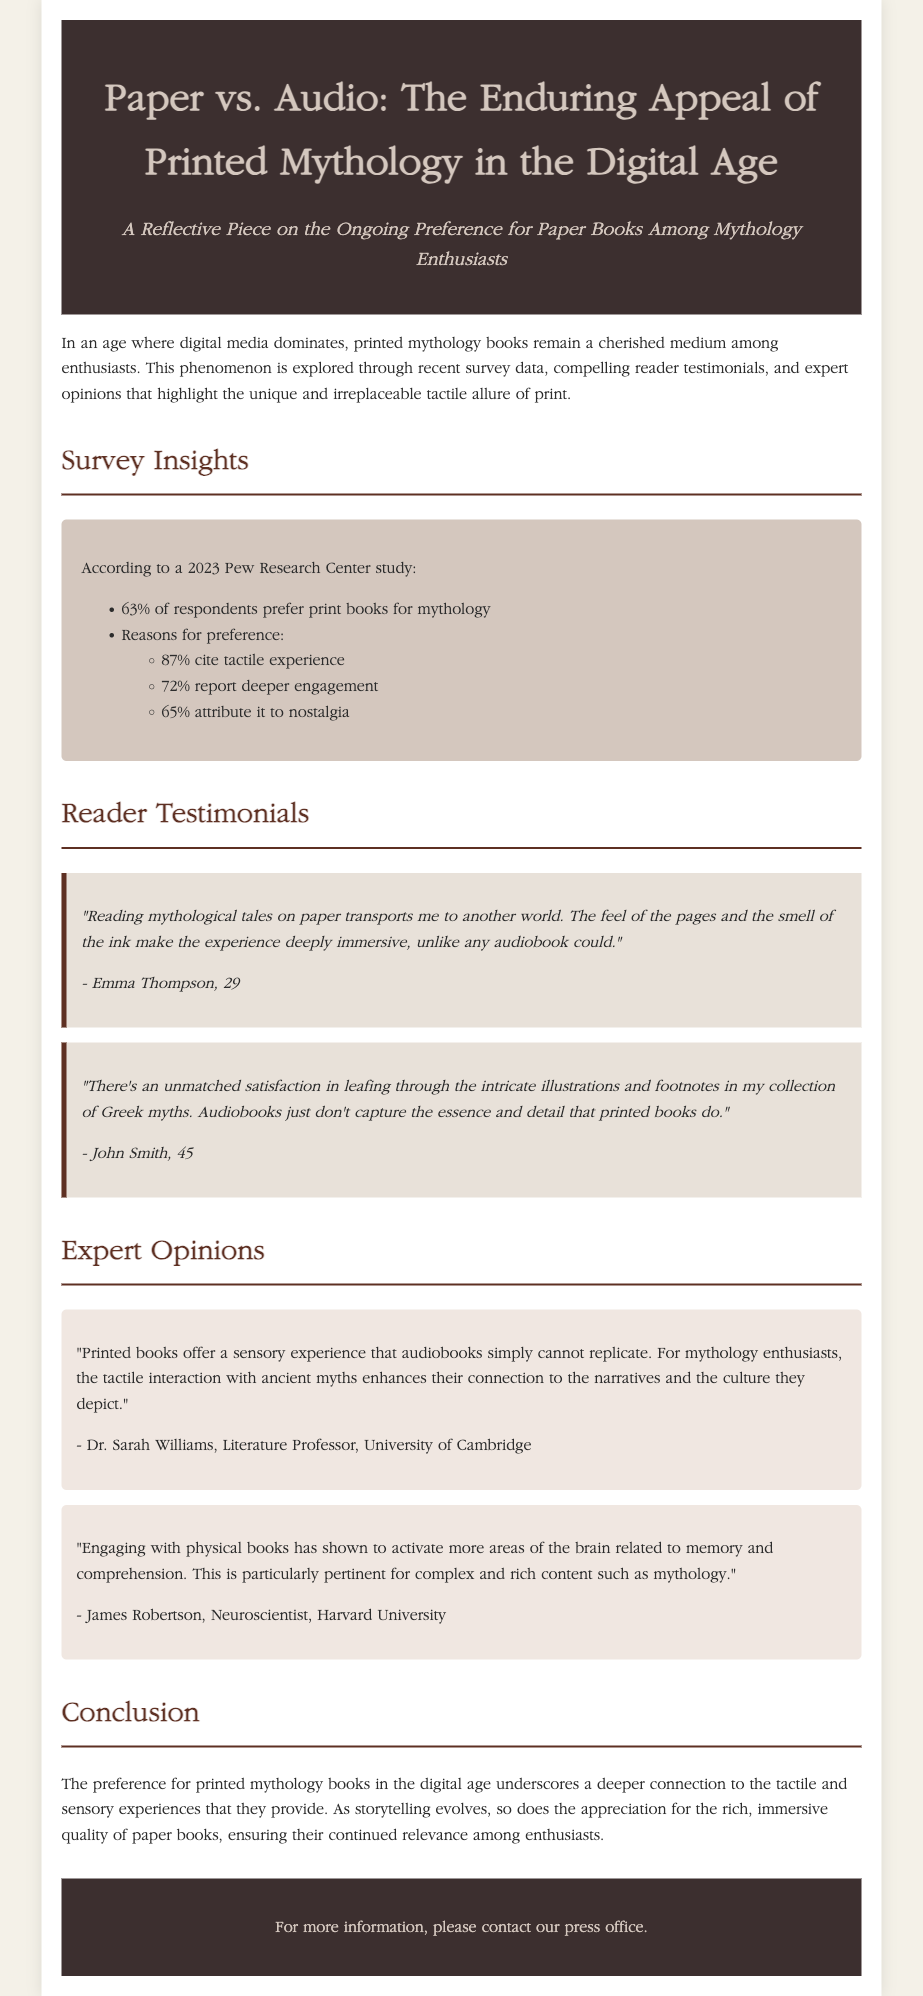what percentage of respondents prefer print books for mythology? The document states that according to the 2023 Pew Research Center study, 63% of respondents prefer print books for mythology.
Answer: 63% what is the main reason for the preference of tangible books according to 87% of respondents? The document indicates that 87% of respondents cite tactile experience as the reason for their preference for printed books.
Answer: tactile experience who is Dr. Sarah Williams? The document describes Dr. Sarah Williams as a Literature Professor at the University of Cambridge who provided an expert opinion on printed books.
Answer: Literature Professor, University of Cambridge what aspect of engagement do 72% of respondents report regarding print books? The document mentions that 72% of respondents report deeper engagement when reading print books compared to digital or audio formats.
Answer: deeper engagement which demographic does Emma Thompson belong to? The document notes that Emma Thompson is 29 years old, which identifies her demographic.
Answer: 29 what sensory experience do printed books offer that audiobooks do not? The document refers to the sensory experience of tactile interaction with printed books, which enhances connections to narratives.
Answer: tactile interaction who graduated from Harvard University and provided expert insight regarding physical books? The document attributes the quote concerning brain activation and comprehension while engaging with physical books to James Robertson, a Neuroscientist from Harvard University.
Answer: James Robertson what is the overall conclusion about printed mythology books in the digital age? The document concludes that the preference for printed mythology books underscores their deeper connection through tactile and sensory experiences.
Answer: deeper connection through tactile and sensory experiences what type of book format is highlighted as 'cherished' among mythology enthusiasts? The document describes printed books as a cherished medium among mythology enthusiasts.
Answer: printed books 